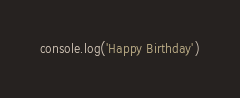<code> <loc_0><loc_0><loc_500><loc_500><_JavaScript_>console.log('Happy Birthday')</code> 